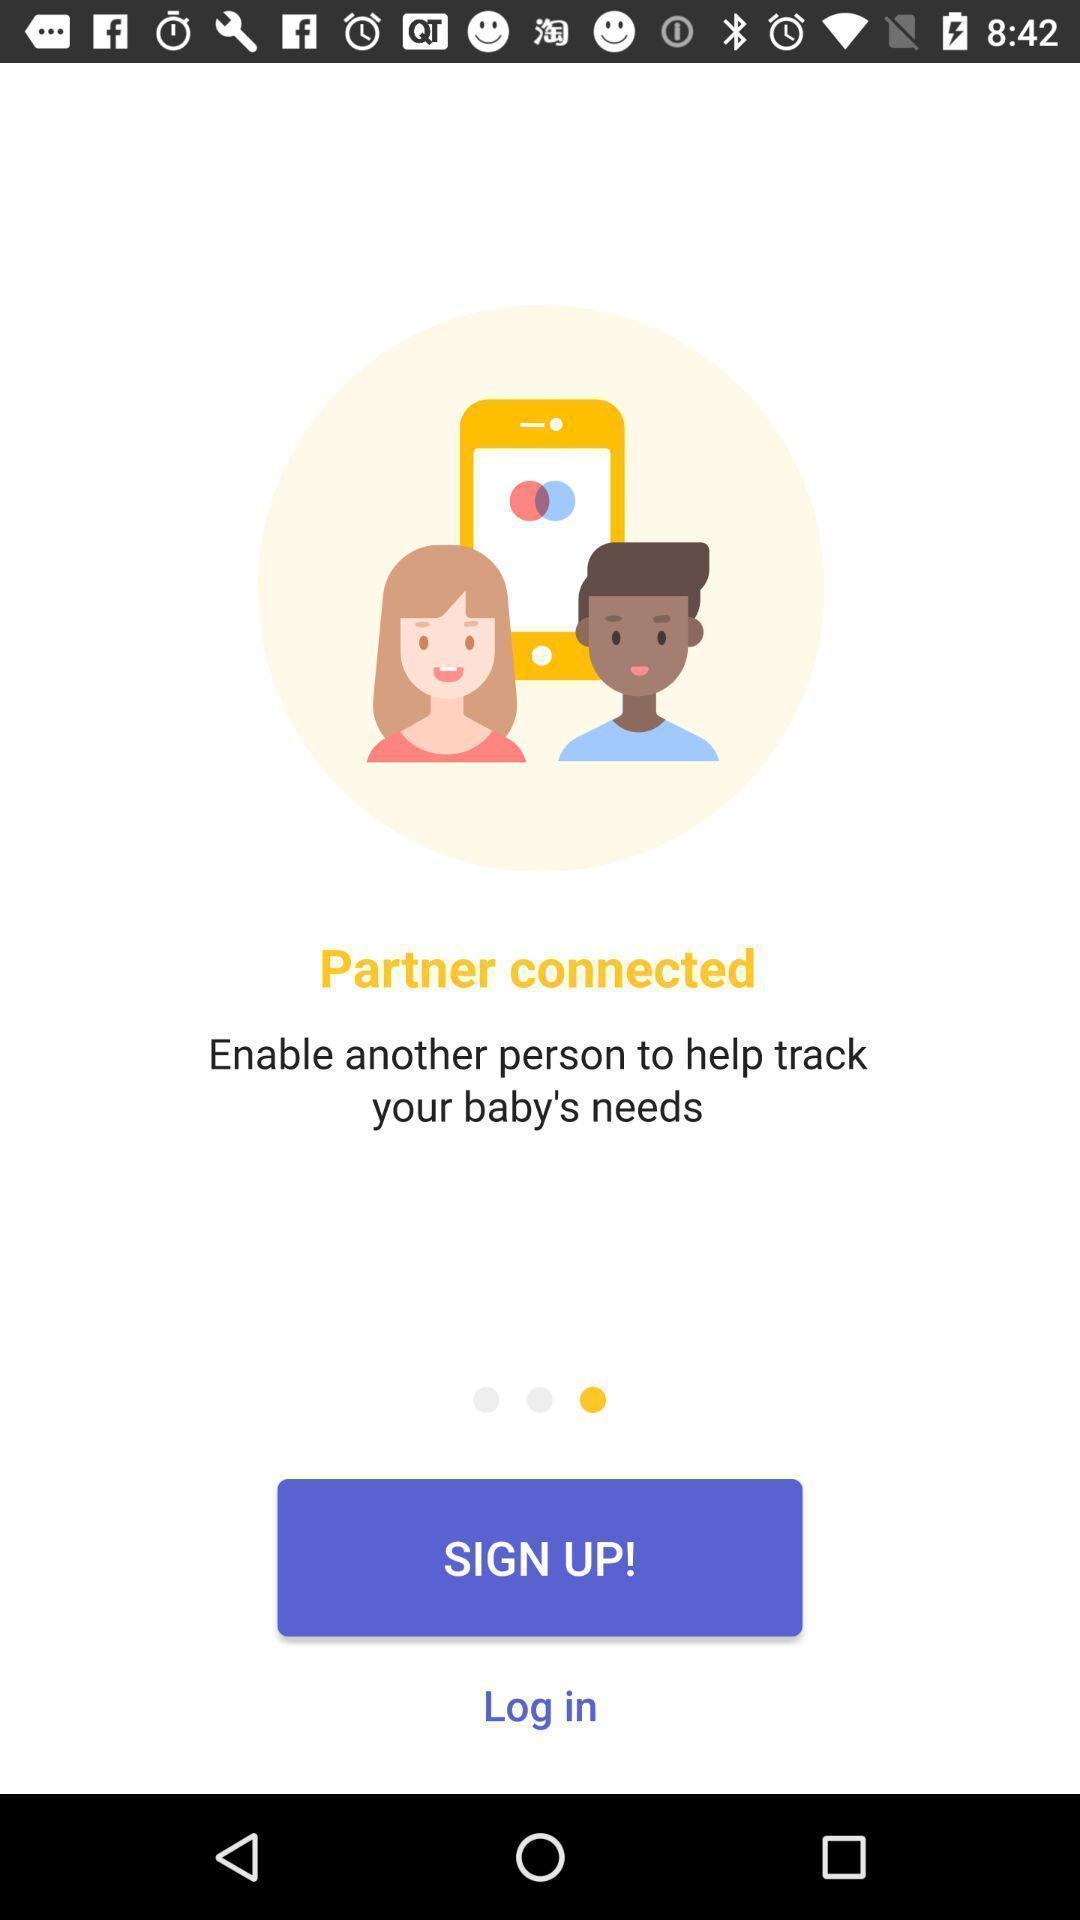Describe the content in this image. Sign up page to get the access form the app. 